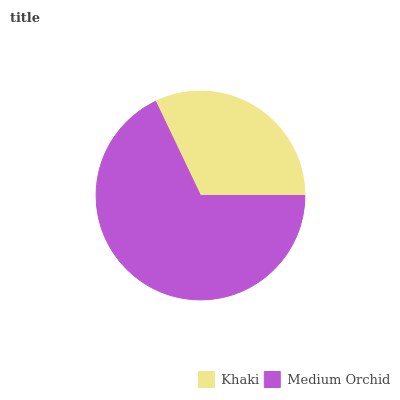Is Khaki the minimum?
Answer yes or no. Yes. Is Medium Orchid the maximum?
Answer yes or no. Yes. Is Medium Orchid the minimum?
Answer yes or no. No. Is Medium Orchid greater than Khaki?
Answer yes or no. Yes. Is Khaki less than Medium Orchid?
Answer yes or no. Yes. Is Khaki greater than Medium Orchid?
Answer yes or no. No. Is Medium Orchid less than Khaki?
Answer yes or no. No. Is Medium Orchid the high median?
Answer yes or no. Yes. Is Khaki the low median?
Answer yes or no. Yes. Is Khaki the high median?
Answer yes or no. No. Is Medium Orchid the low median?
Answer yes or no. No. 